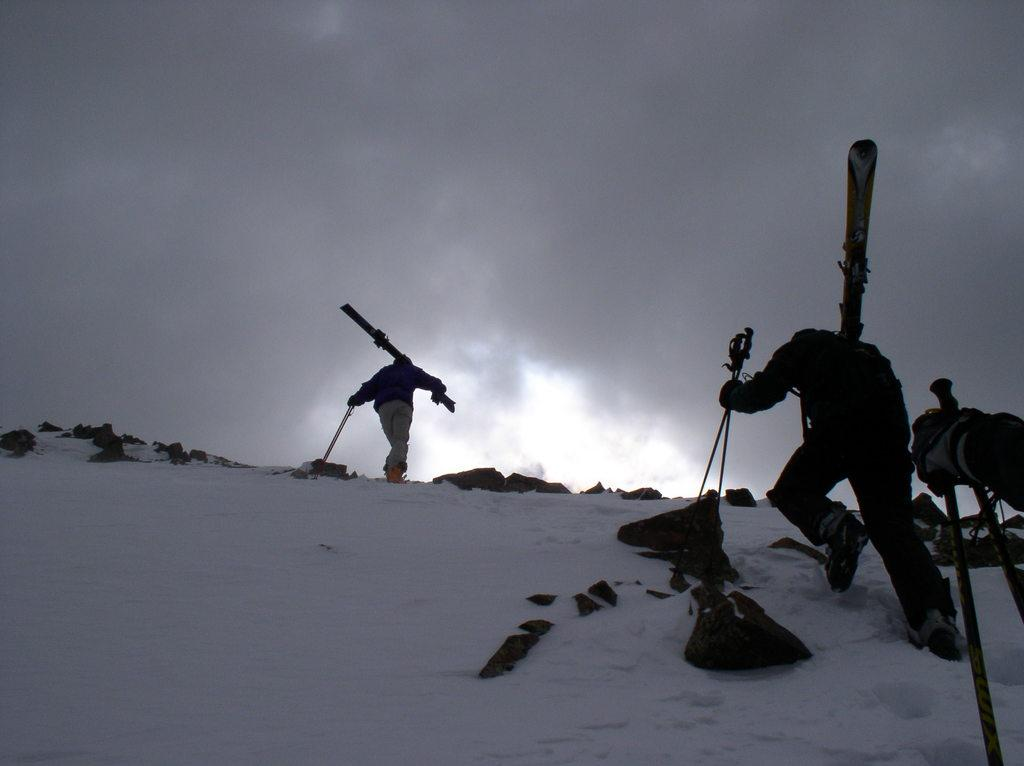How many people are in the image? There are persons in the image, but the exact number cannot be determined from the provided facts. What is the weather like in the image? The presence of snow in the image suggests that it is cold and possibly snowy. What type of terrain is visible in the image? There are rocks in the image, which indicates a rocky terrain. What else can be seen in the image besides the persons, snow, and rocks? There are other objects in the image, but their specific nature cannot be determined from the provided facts. What is visible at the top of the image? The sky is visible at the top of the image. Where is the snow located in the image? The snow is visible at the bottom of the image. How much money is being exchanged between the persons in the image? There is no indication of money or any exchange of money in the image. What type of pleasure can be seen being experienced by the persons in the image? There is no indication of pleasure or any specific activity being experienced by the persons in the image. 